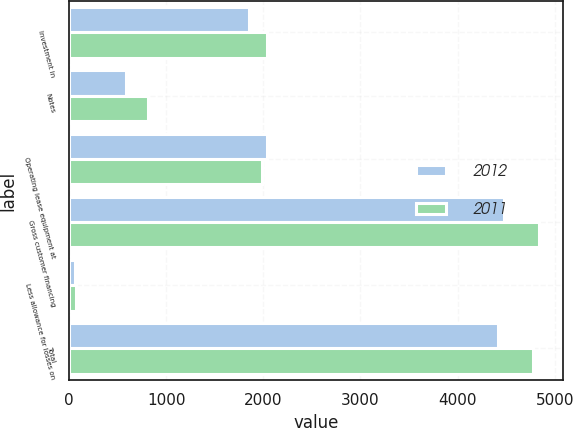Convert chart to OTSL. <chart><loc_0><loc_0><loc_500><loc_500><stacked_bar_chart><ecel><fcel>Investment in<fcel>Notes<fcel>Operating lease equipment at<fcel>Gross customer financing<fcel>Less allowance for losses on<fcel>Total<nl><fcel>2012<fcel>1850<fcel>592<fcel>2038<fcel>4480<fcel>60<fcel>4420<nl><fcel>2011<fcel>2037<fcel>814<fcel>1991<fcel>4842<fcel>70<fcel>4772<nl></chart> 